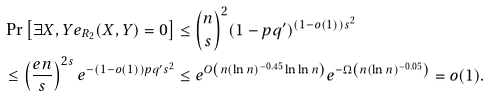Convert formula to latex. <formula><loc_0><loc_0><loc_500><loc_500>& \Pr \left [ \exists X , Y e _ { R _ { 2 } } ( X , Y ) = 0 \right ] \leq \binom { n } { s } ^ { 2 } ( 1 - p q ^ { \prime } ) ^ { ( 1 - o ( 1 ) ) s ^ { 2 } } \\ & \leq \left ( \frac { e n } { s } \right ) ^ { 2 s } e ^ { - ( 1 - o ( 1 ) ) p q ^ { \prime } s ^ { 2 } } \leq e ^ { O \left ( n ( \ln n ) ^ { - 0 . 4 5 } \ln \ln n \right ) } e ^ { - \Omega \left ( n ( \ln n ) ^ { - 0 . 0 5 } \right ) } = o ( 1 ) .</formula> 